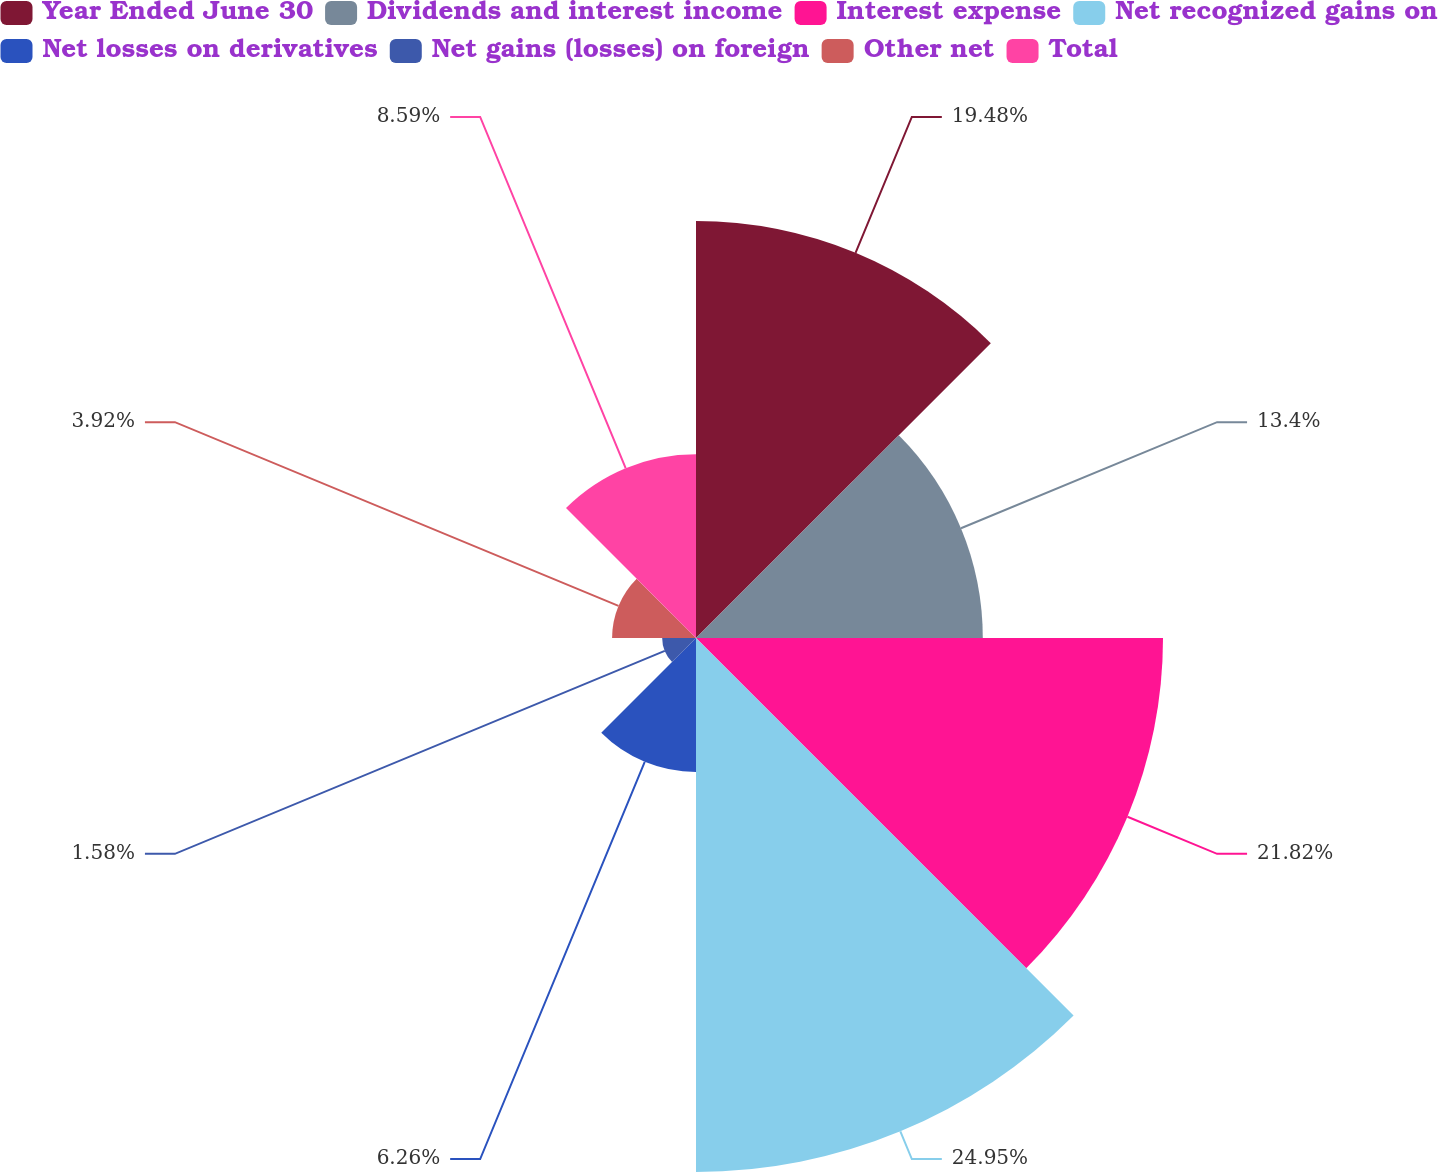Convert chart. <chart><loc_0><loc_0><loc_500><loc_500><pie_chart><fcel>Year Ended June 30<fcel>Dividends and interest income<fcel>Interest expense<fcel>Net recognized gains on<fcel>Net losses on derivatives<fcel>Net gains (losses) on foreign<fcel>Other net<fcel>Total<nl><fcel>19.48%<fcel>13.4%<fcel>21.82%<fcel>24.95%<fcel>6.26%<fcel>1.58%<fcel>3.92%<fcel>8.59%<nl></chart> 